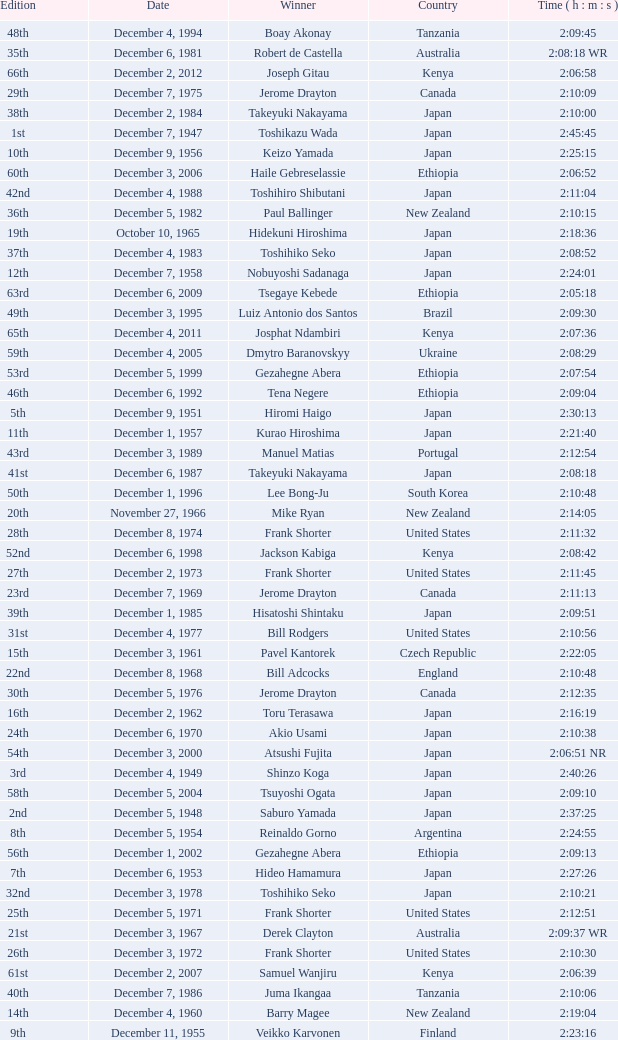On what date was the 48th Edition raced? December 4, 1994. 